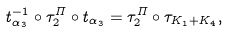<formula> <loc_0><loc_0><loc_500><loc_500>t _ { \alpha _ { 3 } } ^ { - 1 } \circ \tau ^ { \varPi } _ { 2 } \circ t _ { \alpha _ { 3 } } = \tau ^ { \varPi } _ { 2 } \circ \tau _ { K _ { 1 } + K _ { 4 } } ,</formula> 